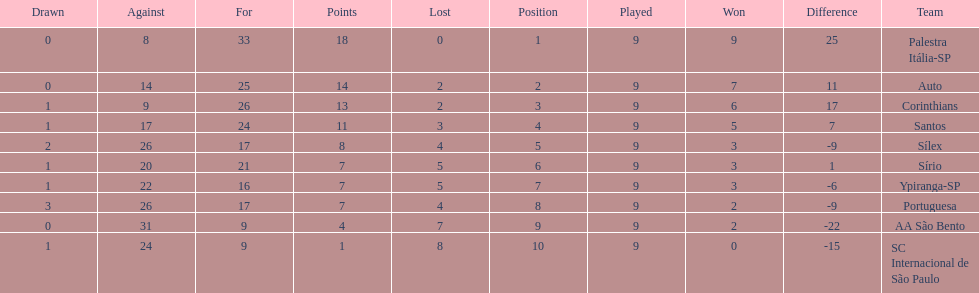Which is the only team to score 13 points in 9 games? Corinthians. 